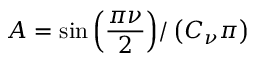<formula> <loc_0><loc_0><loc_500><loc_500>A = \sin { \left ( \frac { \pi \nu } { 2 } \right ) } / \left ( C _ { \nu } \pi \right )</formula> 